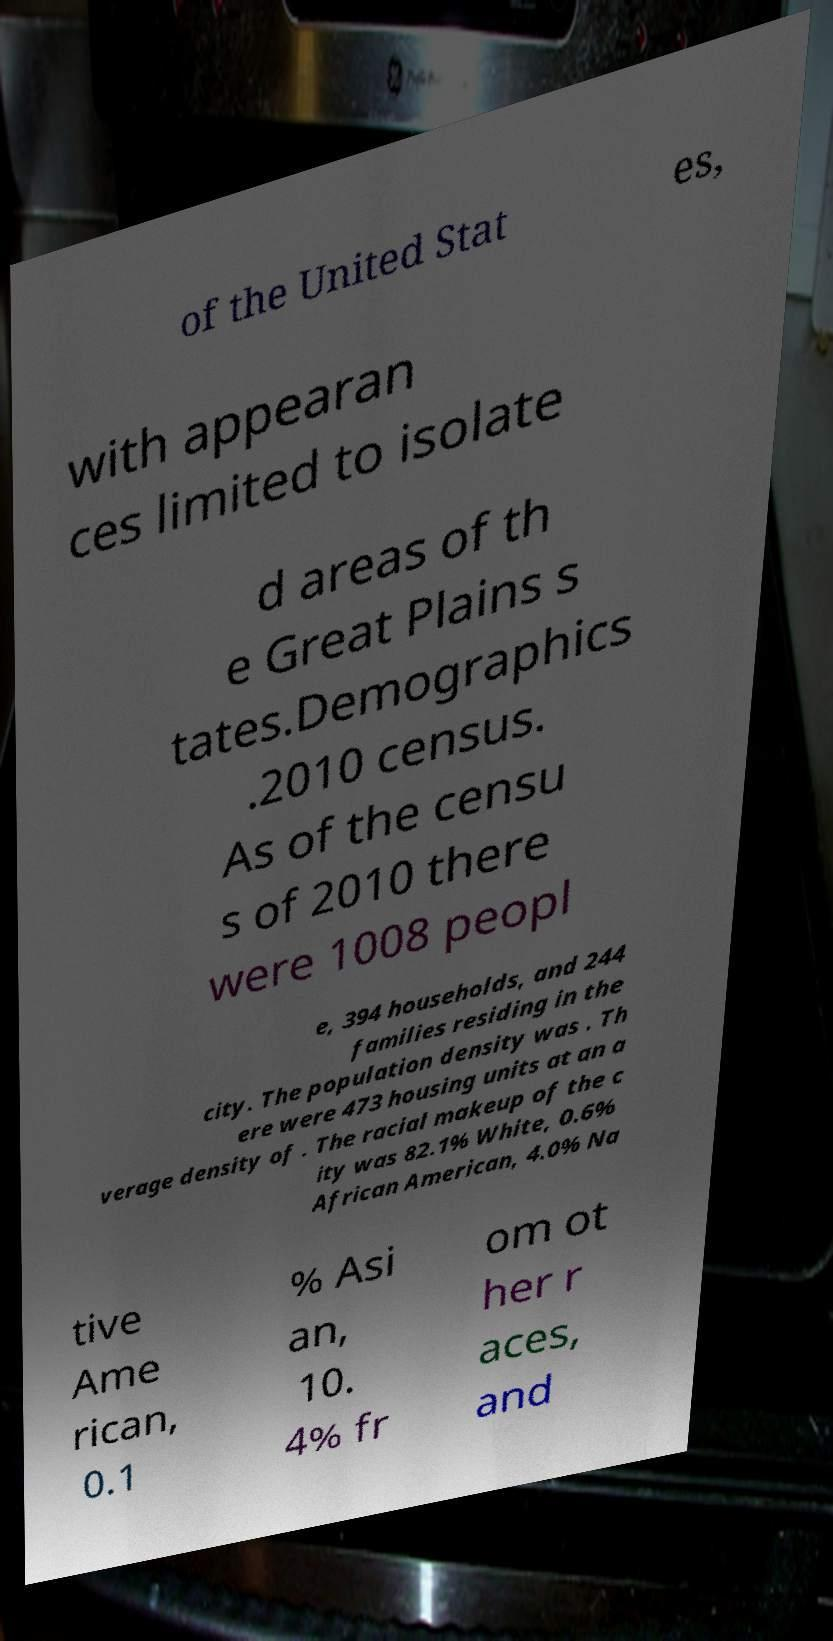Can you read and provide the text displayed in the image?This photo seems to have some interesting text. Can you extract and type it out for me? of the United Stat es, with appearan ces limited to isolate d areas of th e Great Plains s tates.Demographics .2010 census. As of the censu s of 2010 there were 1008 peopl e, 394 households, and 244 families residing in the city. The population density was . Th ere were 473 housing units at an a verage density of . The racial makeup of the c ity was 82.1% White, 0.6% African American, 4.0% Na tive Ame rican, 0.1 % Asi an, 10. 4% fr om ot her r aces, and 